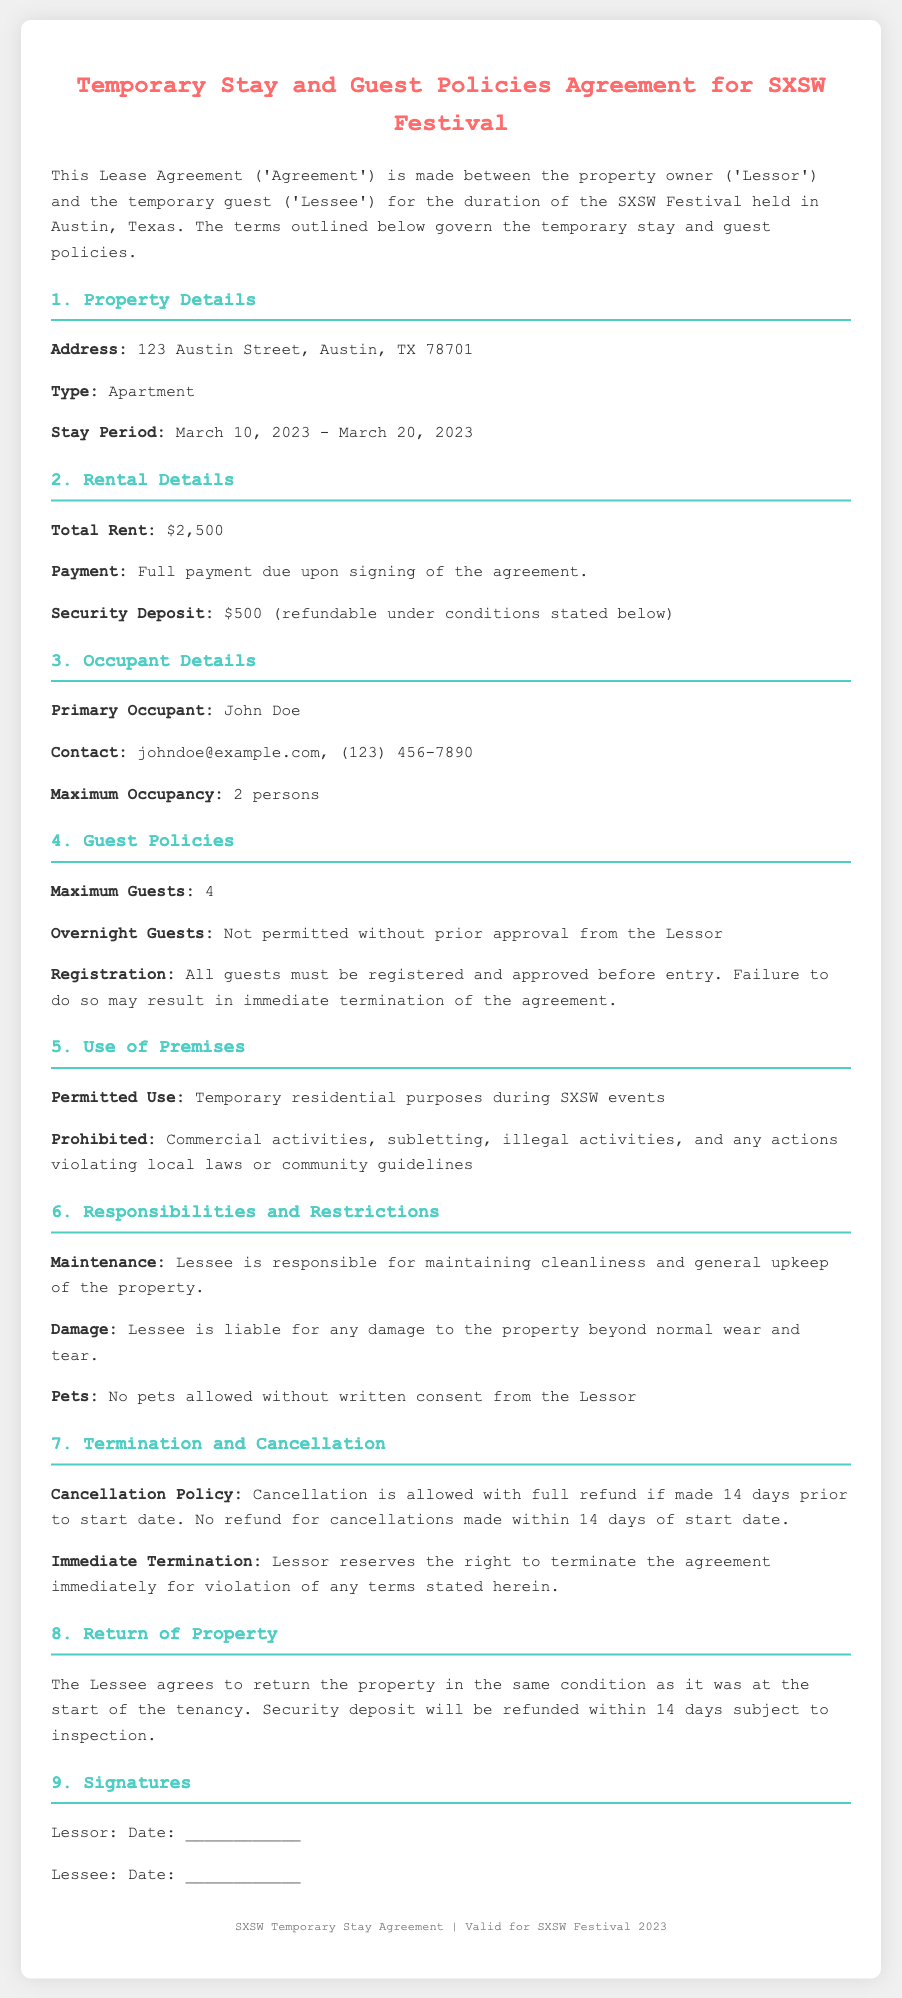What is the address of the property? The document specifies the address where the temporary stay takes place, which is located at 123 Austin Street, Austin, TX 78701.
Answer: 123 Austin Street, Austin, TX 78701 What is the total rent for the stay? The total rent is explicitly stated in the rental details section of the document as $2,500.
Answer: $2,500 What is the maximum occupancy allowed? The maximum occupancy is mentioned in the occupant details section, which allows up to 2 persons in the property.
Answer: 2 persons What is the security deposit amount? The security deposit amount is directly stated in the rental details section as $500.
Answer: $500 Are overnight guests permitted? The guest policies section mentions that overnight guests are not permitted without prior approval from the Lessor.
Answer: Not permitted How many guests can register? According to the guest policies section, a maximum of 4 guests are allowed to register in the property.
Answer: 4 What is the cancellation policy? The cancellation policy is described in the termination and cancellation section, which states full refund if cancellation is made 14 days prior to the start date.
Answer: Full refund if made 14 days prior Who is the primary occupant? The primary occupant's name and details are listed in the occupant details section, which states John Doe as the primary occupant.
Answer: John Doe What is the permitted use of the property? The document outlines the permitted use of the property for temporary residential purposes during SXSW events.
Answer: Temporary residential purposes during SXSW events 